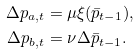Convert formula to latex. <formula><loc_0><loc_0><loc_500><loc_500>\Delta p _ { a , t } & = \mu \xi ( \bar { p } _ { t - 1 } ) , \\ \Delta p _ { b , t } & = \nu \Delta { \bar { p } } _ { t - 1 } .</formula> 